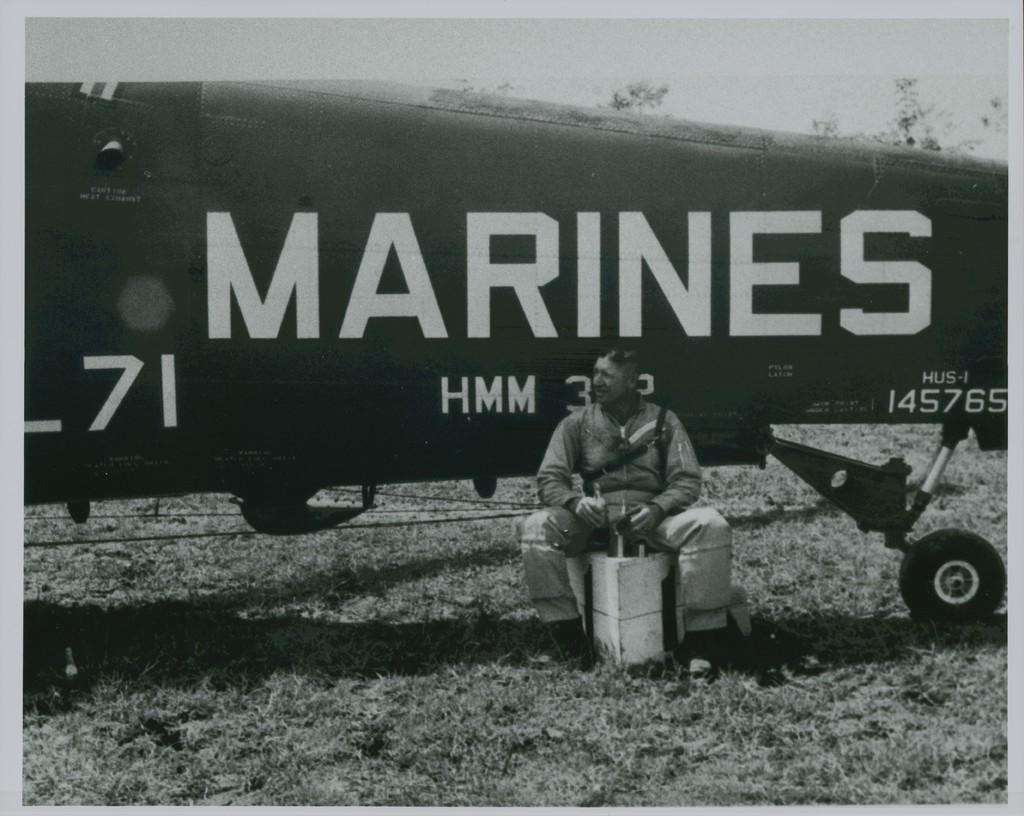<image>
Give a short and clear explanation of the subsequent image. A man who is a marine is sitting on a box with a plane in the background. 